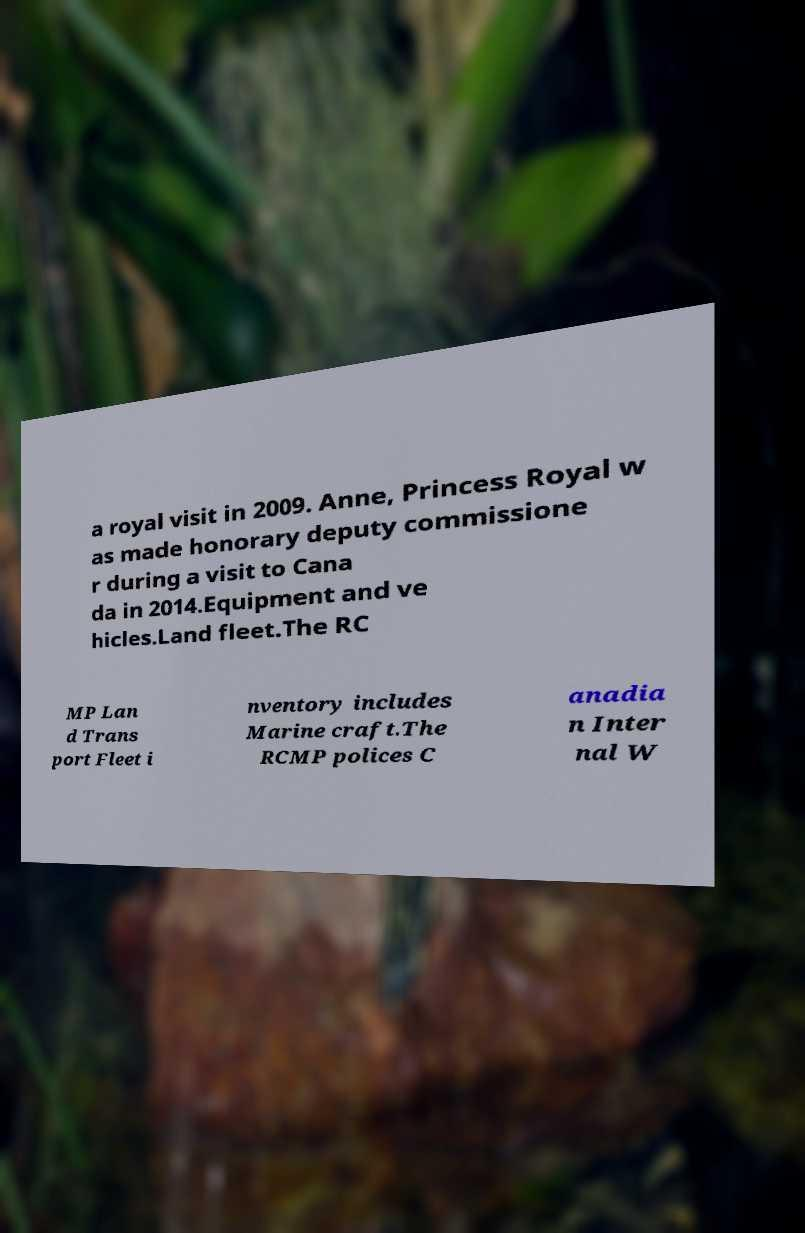I need the written content from this picture converted into text. Can you do that? a royal visit in 2009. Anne, Princess Royal w as made honorary deputy commissione r during a visit to Cana da in 2014.Equipment and ve hicles.Land fleet.The RC MP Lan d Trans port Fleet i nventory includes Marine craft.The RCMP polices C anadia n Inter nal W 